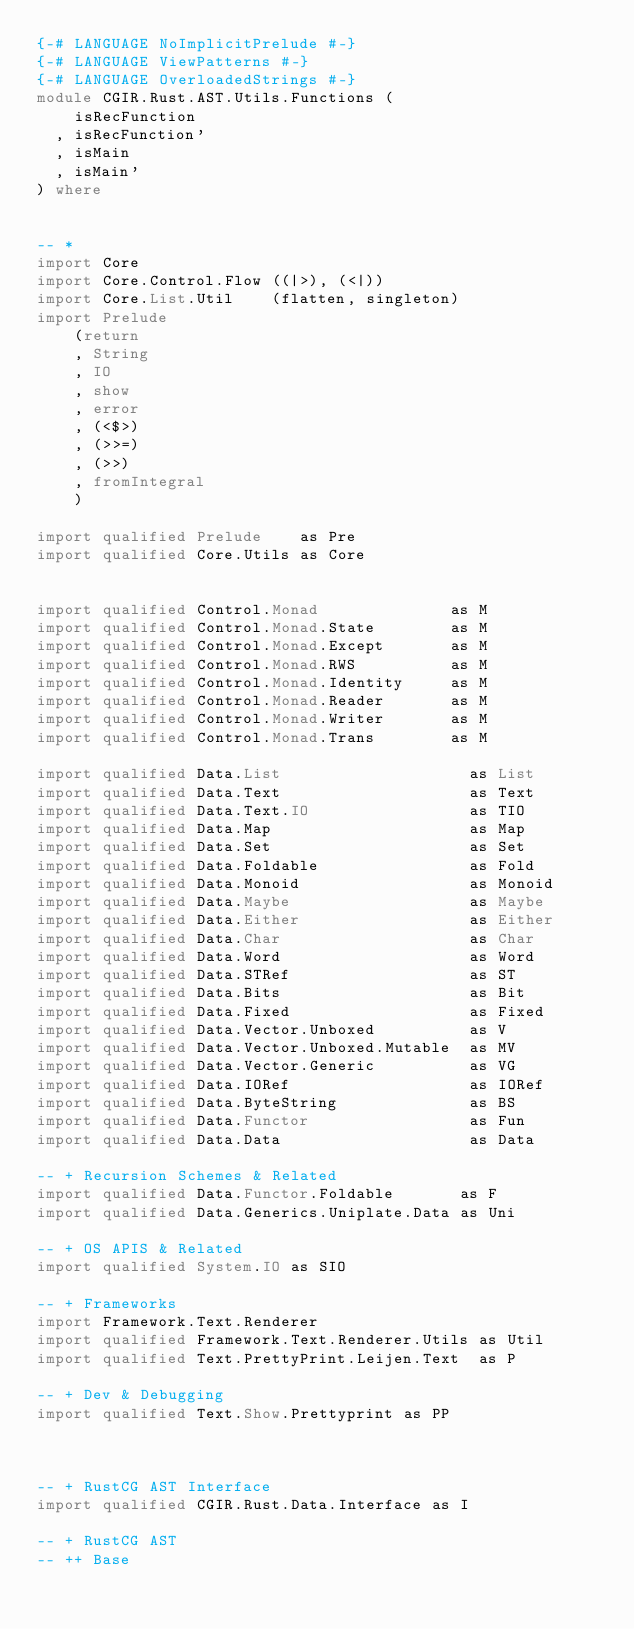<code> <loc_0><loc_0><loc_500><loc_500><_Haskell_>{-# LANGUAGE NoImplicitPrelude #-}
{-# LANGUAGE ViewPatterns #-}
{-# LANGUAGE OverloadedStrings #-}
module CGIR.Rust.AST.Utils.Functions (
    isRecFunction
  , isRecFunction'
  , isMain
  , isMain'
) where


-- *
import Core
import Core.Control.Flow ((|>), (<|))
import Core.List.Util    (flatten, singleton)
import Prelude
    (return
    , String
    , IO
    , show
    , error
    , (<$>)
    , (>>=)
    , (>>)
    , fromIntegral
    )

import qualified Prelude    as Pre
import qualified Core.Utils as Core


import qualified Control.Monad              as M
import qualified Control.Monad.State        as M
import qualified Control.Monad.Except       as M
import qualified Control.Monad.RWS          as M
import qualified Control.Monad.Identity     as M
import qualified Control.Monad.Reader       as M
import qualified Control.Monad.Writer       as M
import qualified Control.Monad.Trans        as M

import qualified Data.List                    as List
import qualified Data.Text                    as Text
import qualified Data.Text.IO                 as TIO
import qualified Data.Map                     as Map
import qualified Data.Set                     as Set
import qualified Data.Foldable                as Fold
import qualified Data.Monoid                  as Monoid
import qualified Data.Maybe                   as Maybe
import qualified Data.Either                  as Either
import qualified Data.Char                    as Char
import qualified Data.Word                    as Word
import qualified Data.STRef                   as ST
import qualified Data.Bits                    as Bit
import qualified Data.Fixed                   as Fixed
import qualified Data.Vector.Unboxed          as V
import qualified Data.Vector.Unboxed.Mutable  as MV
import qualified Data.Vector.Generic          as VG
import qualified Data.IORef                   as IORef
import qualified Data.ByteString              as BS
import qualified Data.Functor                 as Fun
import qualified Data.Data                    as Data

-- + Recursion Schemes & Related
import qualified Data.Functor.Foldable       as F
import qualified Data.Generics.Uniplate.Data as Uni

-- + OS APIS & Related
import qualified System.IO as SIO

-- + Frameworks
import Framework.Text.Renderer
import qualified Framework.Text.Renderer.Utils as Util
import qualified Text.PrettyPrint.Leijen.Text  as P

-- + Dev & Debugging
import qualified Text.Show.Prettyprint as PP



-- + RustCG AST Interface
import qualified CGIR.Rust.Data.Interface as I

-- + RustCG AST
-- ++ Base</code> 